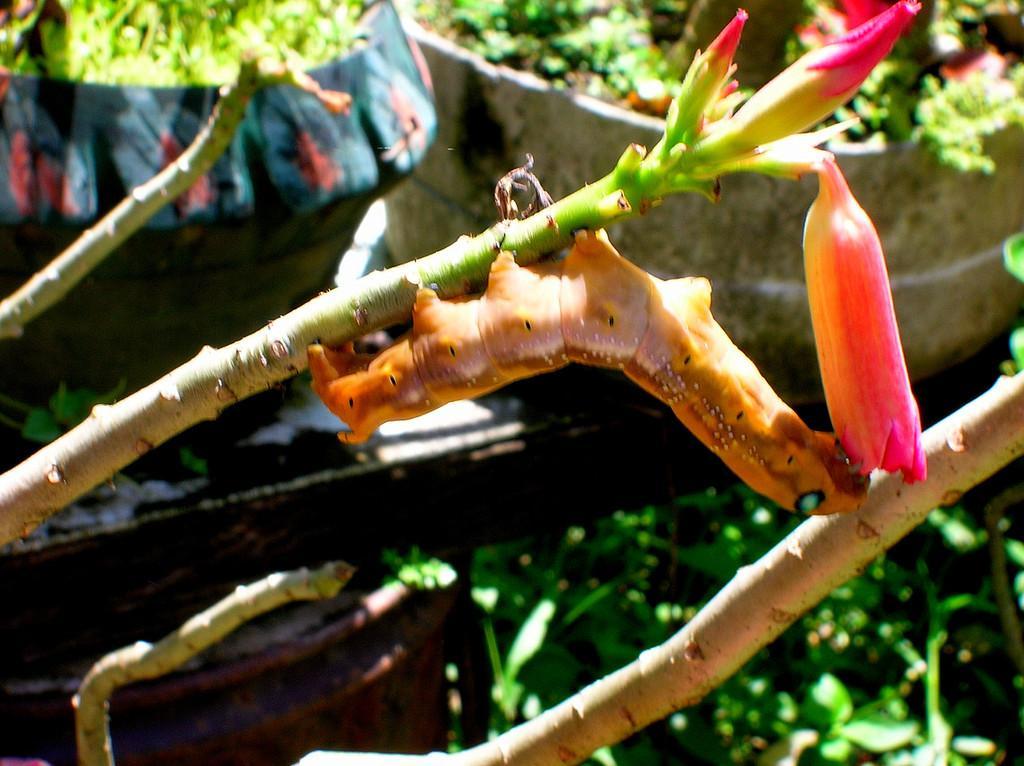In one or two sentences, can you explain what this image depicts? In this image there is a caterpillar which is eating the flower. In the background there is a flower pot. At the bottom there are plants. 